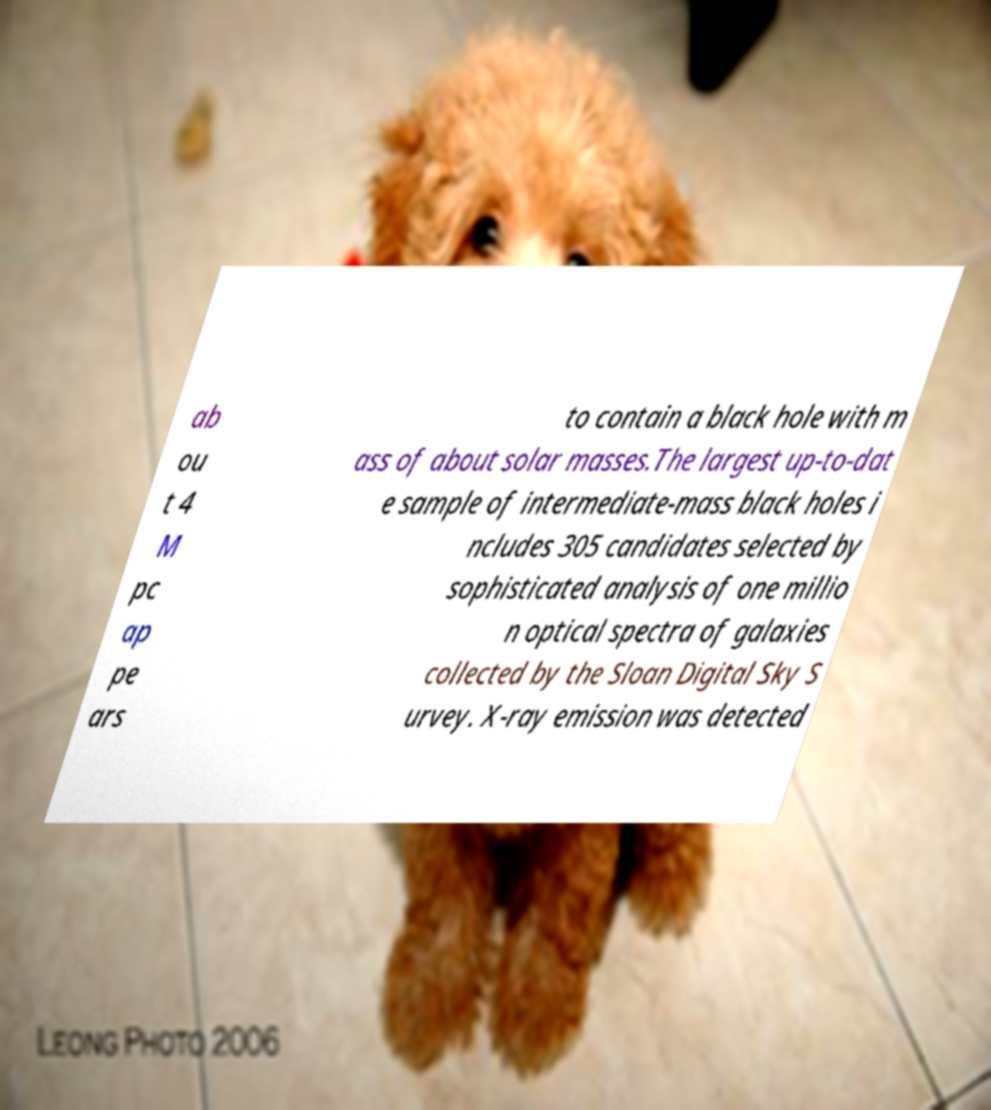What messages or text are displayed in this image? I need them in a readable, typed format. ab ou t 4 M pc ap pe ars to contain a black hole with m ass of about solar masses.The largest up-to-dat e sample of intermediate-mass black holes i ncludes 305 candidates selected by sophisticated analysis of one millio n optical spectra of galaxies collected by the Sloan Digital Sky S urvey. X-ray emission was detected 